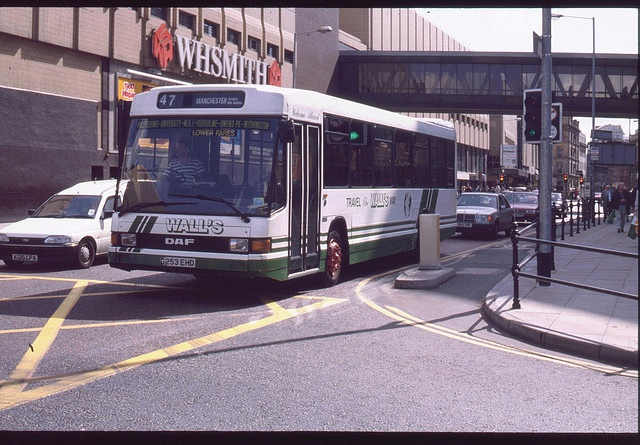Describe the objects in this image and their specific colors. I can see bus in black, navy, gray, and lavender tones, car in black, white, gray, and darkgray tones, car in black and gray tones, people in black, navy, purple, and gray tones, and traffic light in black, gray, and purple tones in this image. 